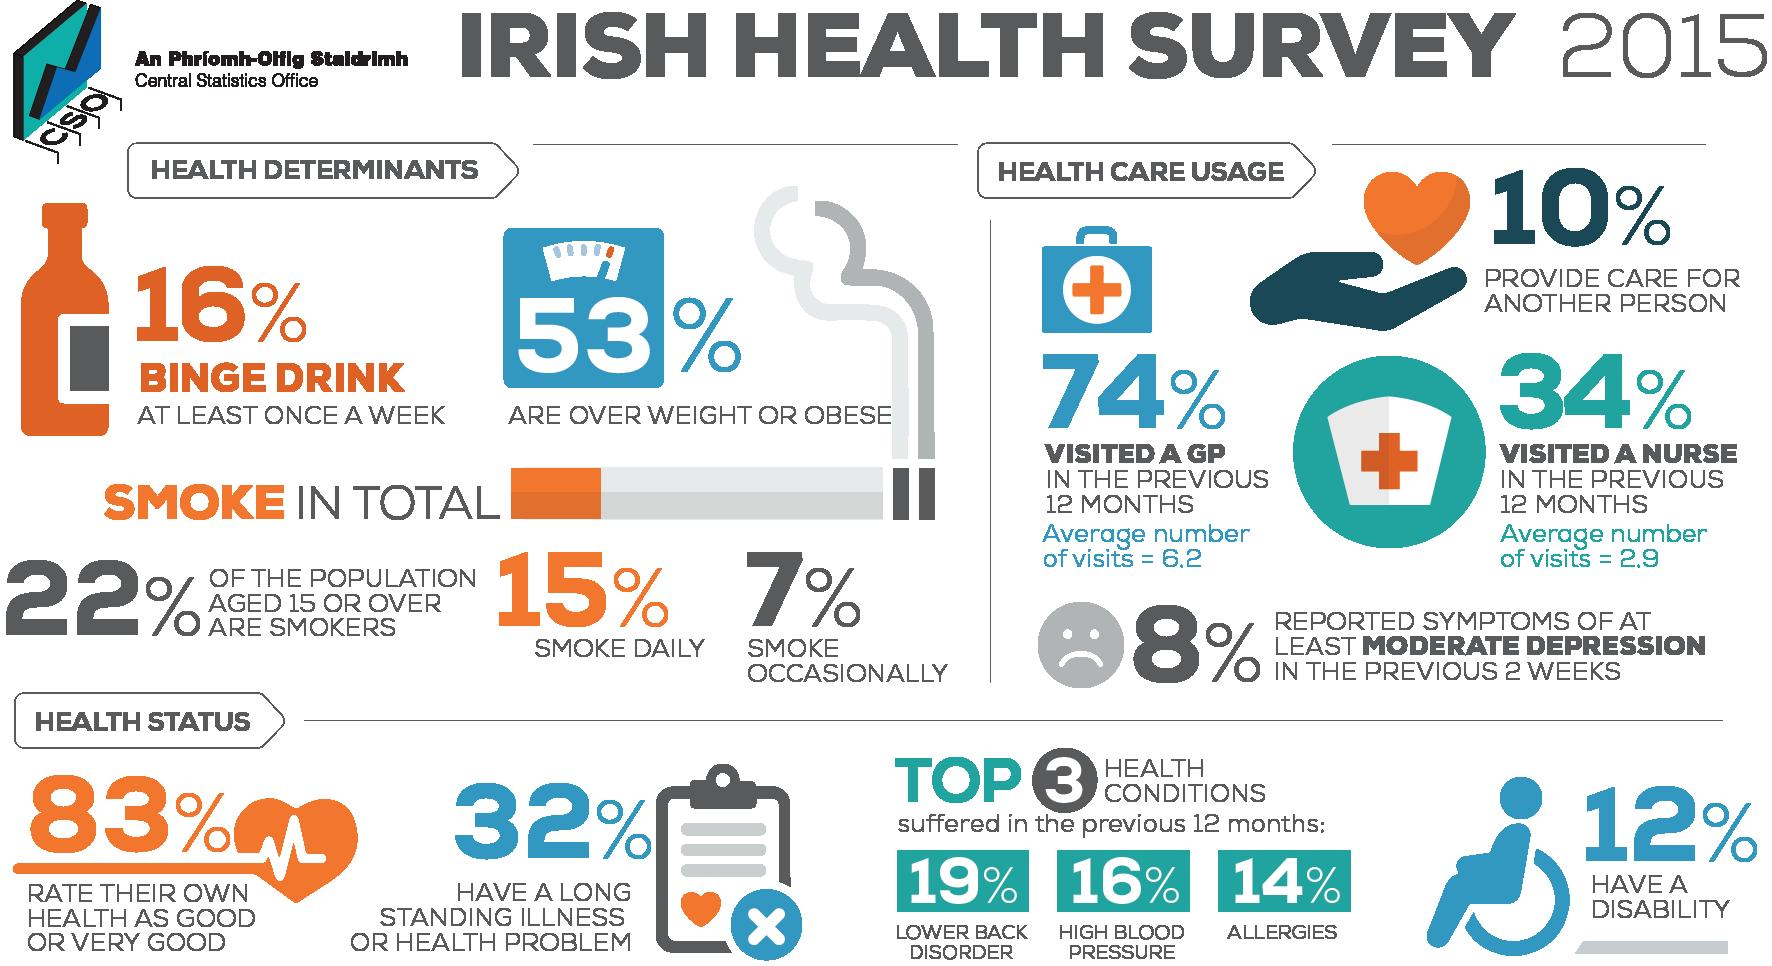Give some essential details in this illustration. According to the Irish Health Survey in 2015, approximately 15% of the Irish population smokes daily. According to the Irish Health Survey in 2015, a majority of the Irish population, approximately 68%, do not suffer from a long-standing illness. According to the Irish Health Survey in 2015, 47% of the Irish population is not obese. According to the health survey conducted in 2015, approximately 19% of the Irish population reported suffering from lower back disorder in the previous 12 months. According to the Irish Health Survey in 2015, 83% of the Irish people reported that their own health was good. 